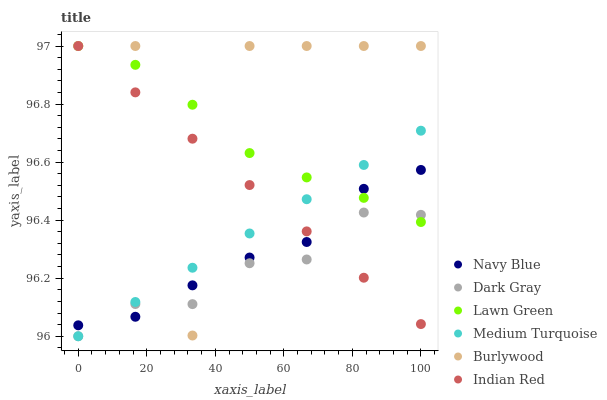Does Dark Gray have the minimum area under the curve?
Answer yes or no. Yes. Does Burlywood have the maximum area under the curve?
Answer yes or no. Yes. Does Medium Turquoise have the minimum area under the curve?
Answer yes or no. No. Does Medium Turquoise have the maximum area under the curve?
Answer yes or no. No. Is Medium Turquoise the smoothest?
Answer yes or no. Yes. Is Burlywood the roughest?
Answer yes or no. Yes. Is Burlywood the smoothest?
Answer yes or no. No. Is Medium Turquoise the roughest?
Answer yes or no. No. Does Medium Turquoise have the lowest value?
Answer yes or no. Yes. Does Burlywood have the lowest value?
Answer yes or no. No. Does Indian Red have the highest value?
Answer yes or no. Yes. Does Medium Turquoise have the highest value?
Answer yes or no. No. Does Navy Blue intersect Lawn Green?
Answer yes or no. Yes. Is Navy Blue less than Lawn Green?
Answer yes or no. No. Is Navy Blue greater than Lawn Green?
Answer yes or no. No. 